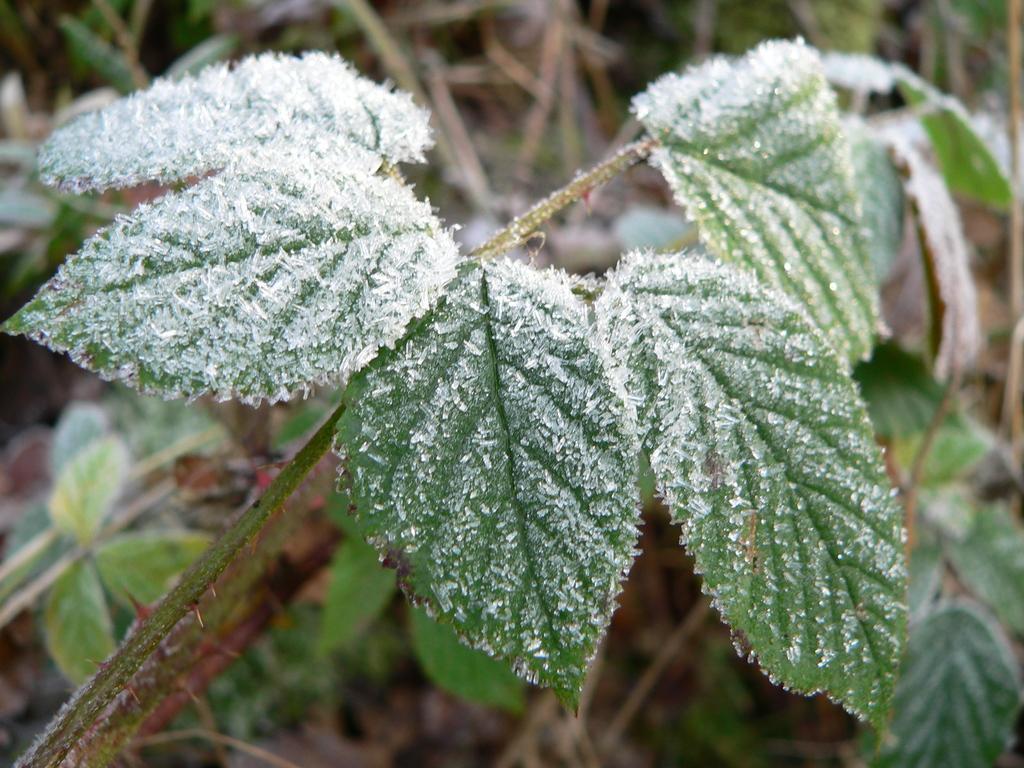Can you describe this image briefly? In this image we can see a plant, there are leaves, there is a frost on it. 